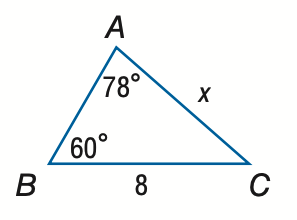Question: Find x. Round to the nearest tenth.
Choices:
A. 3.3
B. 7.1
C. 9.0
D. 19.2
Answer with the letter. Answer: B 